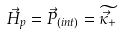Convert formula to latex. <formula><loc_0><loc_0><loc_500><loc_500>\vec { H } _ { p } = \vec { P } _ { ( i n t ) } = \widetilde { \vec { \kappa } _ { + } }</formula> 